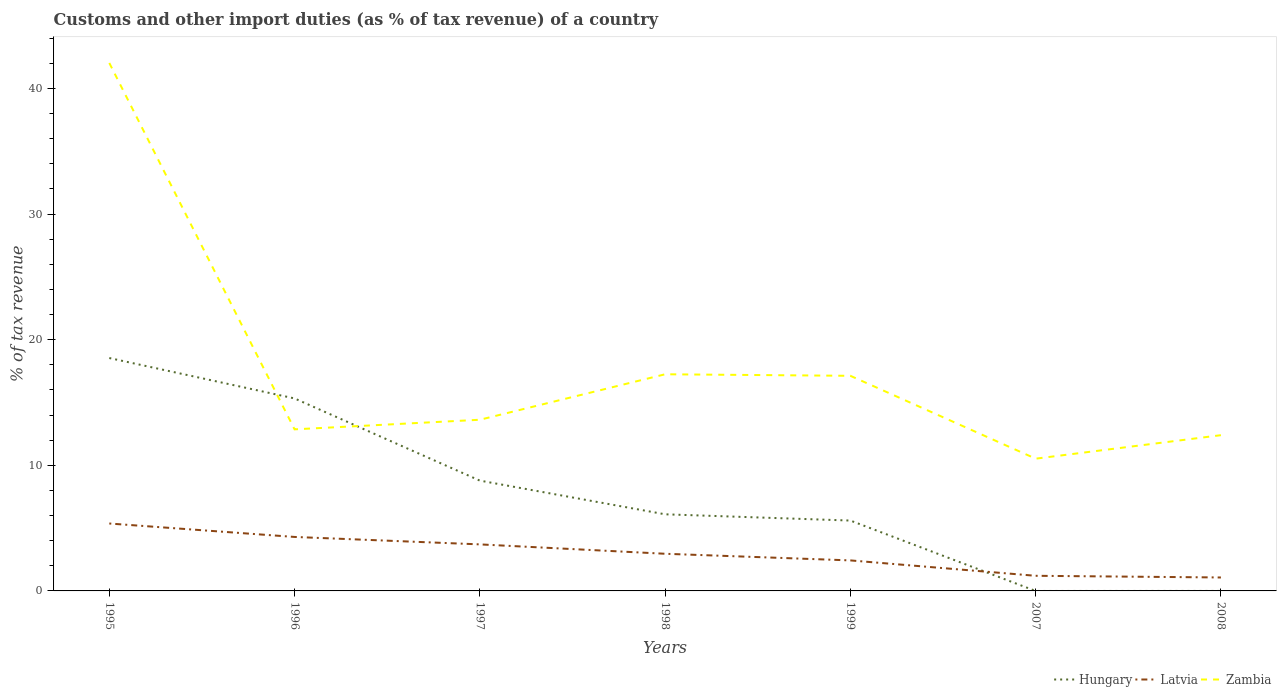Is the number of lines equal to the number of legend labels?
Ensure brevity in your answer.  No. What is the total percentage of tax revenue from customs in Zambia in the graph?
Ensure brevity in your answer.  24.9. What is the difference between the highest and the second highest percentage of tax revenue from customs in Latvia?
Give a very brief answer. 4.3. What is the difference between the highest and the lowest percentage of tax revenue from customs in Hungary?
Make the answer very short. 3. Is the percentage of tax revenue from customs in Hungary strictly greater than the percentage of tax revenue from customs in Latvia over the years?
Offer a very short reply. No. Are the values on the major ticks of Y-axis written in scientific E-notation?
Give a very brief answer. No. Does the graph contain any zero values?
Offer a terse response. Yes. Where does the legend appear in the graph?
Your answer should be compact. Bottom right. How are the legend labels stacked?
Give a very brief answer. Horizontal. What is the title of the graph?
Provide a short and direct response. Customs and other import duties (as % of tax revenue) of a country. What is the label or title of the Y-axis?
Offer a very short reply. % of tax revenue. What is the % of tax revenue of Hungary in 1995?
Provide a succinct answer. 18.54. What is the % of tax revenue in Latvia in 1995?
Ensure brevity in your answer.  5.37. What is the % of tax revenue in Zambia in 1995?
Keep it short and to the point. 42.02. What is the % of tax revenue of Hungary in 1996?
Keep it short and to the point. 15.32. What is the % of tax revenue of Latvia in 1996?
Provide a short and direct response. 4.3. What is the % of tax revenue in Zambia in 1996?
Give a very brief answer. 12.86. What is the % of tax revenue of Hungary in 1997?
Make the answer very short. 8.78. What is the % of tax revenue in Latvia in 1997?
Ensure brevity in your answer.  3.7. What is the % of tax revenue of Zambia in 1997?
Provide a succinct answer. 13.62. What is the % of tax revenue of Hungary in 1998?
Provide a succinct answer. 6.1. What is the % of tax revenue of Latvia in 1998?
Your answer should be very brief. 2.96. What is the % of tax revenue of Zambia in 1998?
Make the answer very short. 17.24. What is the % of tax revenue in Hungary in 1999?
Make the answer very short. 5.6. What is the % of tax revenue in Latvia in 1999?
Your answer should be very brief. 2.43. What is the % of tax revenue of Zambia in 1999?
Make the answer very short. 17.12. What is the % of tax revenue of Latvia in 2007?
Provide a succinct answer. 1.2. What is the % of tax revenue of Zambia in 2007?
Your answer should be compact. 10.53. What is the % of tax revenue in Hungary in 2008?
Provide a succinct answer. 0. What is the % of tax revenue of Latvia in 2008?
Offer a very short reply. 1.07. What is the % of tax revenue of Zambia in 2008?
Your answer should be very brief. 12.4. Across all years, what is the maximum % of tax revenue in Hungary?
Provide a succinct answer. 18.54. Across all years, what is the maximum % of tax revenue of Latvia?
Ensure brevity in your answer.  5.37. Across all years, what is the maximum % of tax revenue of Zambia?
Keep it short and to the point. 42.02. Across all years, what is the minimum % of tax revenue in Latvia?
Make the answer very short. 1.07. Across all years, what is the minimum % of tax revenue of Zambia?
Offer a very short reply. 10.53. What is the total % of tax revenue of Hungary in the graph?
Offer a very short reply. 54.34. What is the total % of tax revenue of Latvia in the graph?
Keep it short and to the point. 21.03. What is the total % of tax revenue in Zambia in the graph?
Provide a short and direct response. 125.8. What is the difference between the % of tax revenue in Hungary in 1995 and that in 1996?
Keep it short and to the point. 3.22. What is the difference between the % of tax revenue of Latvia in 1995 and that in 1996?
Your answer should be compact. 1.07. What is the difference between the % of tax revenue of Zambia in 1995 and that in 1996?
Ensure brevity in your answer.  29.16. What is the difference between the % of tax revenue of Hungary in 1995 and that in 1997?
Give a very brief answer. 9.76. What is the difference between the % of tax revenue in Latvia in 1995 and that in 1997?
Provide a succinct answer. 1.66. What is the difference between the % of tax revenue in Zambia in 1995 and that in 1997?
Offer a very short reply. 28.4. What is the difference between the % of tax revenue in Hungary in 1995 and that in 1998?
Offer a very short reply. 12.44. What is the difference between the % of tax revenue of Latvia in 1995 and that in 1998?
Keep it short and to the point. 2.41. What is the difference between the % of tax revenue of Zambia in 1995 and that in 1998?
Provide a short and direct response. 24.78. What is the difference between the % of tax revenue of Hungary in 1995 and that in 1999?
Offer a terse response. 12.94. What is the difference between the % of tax revenue of Latvia in 1995 and that in 1999?
Offer a very short reply. 2.94. What is the difference between the % of tax revenue of Zambia in 1995 and that in 1999?
Provide a succinct answer. 24.9. What is the difference between the % of tax revenue of Latvia in 1995 and that in 2007?
Your answer should be compact. 4.16. What is the difference between the % of tax revenue of Zambia in 1995 and that in 2007?
Provide a succinct answer. 31.5. What is the difference between the % of tax revenue in Latvia in 1995 and that in 2008?
Provide a succinct answer. 4.3. What is the difference between the % of tax revenue in Zambia in 1995 and that in 2008?
Keep it short and to the point. 29.63. What is the difference between the % of tax revenue of Hungary in 1996 and that in 1997?
Your response must be concise. 6.54. What is the difference between the % of tax revenue in Latvia in 1996 and that in 1997?
Provide a short and direct response. 0.59. What is the difference between the % of tax revenue in Zambia in 1996 and that in 1997?
Give a very brief answer. -0.76. What is the difference between the % of tax revenue in Hungary in 1996 and that in 1998?
Your answer should be compact. 9.22. What is the difference between the % of tax revenue of Latvia in 1996 and that in 1998?
Offer a terse response. 1.34. What is the difference between the % of tax revenue of Zambia in 1996 and that in 1998?
Give a very brief answer. -4.38. What is the difference between the % of tax revenue in Hungary in 1996 and that in 1999?
Provide a short and direct response. 9.72. What is the difference between the % of tax revenue in Latvia in 1996 and that in 1999?
Keep it short and to the point. 1.87. What is the difference between the % of tax revenue in Zambia in 1996 and that in 1999?
Keep it short and to the point. -4.26. What is the difference between the % of tax revenue in Latvia in 1996 and that in 2007?
Give a very brief answer. 3.09. What is the difference between the % of tax revenue in Zambia in 1996 and that in 2007?
Give a very brief answer. 2.33. What is the difference between the % of tax revenue in Latvia in 1996 and that in 2008?
Your response must be concise. 3.23. What is the difference between the % of tax revenue in Zambia in 1996 and that in 2008?
Provide a short and direct response. 0.46. What is the difference between the % of tax revenue in Hungary in 1997 and that in 1998?
Offer a terse response. 2.68. What is the difference between the % of tax revenue in Latvia in 1997 and that in 1998?
Offer a terse response. 0.75. What is the difference between the % of tax revenue in Zambia in 1997 and that in 1998?
Provide a succinct answer. -3.62. What is the difference between the % of tax revenue in Hungary in 1997 and that in 1999?
Make the answer very short. 3.18. What is the difference between the % of tax revenue of Latvia in 1997 and that in 1999?
Your answer should be very brief. 1.28. What is the difference between the % of tax revenue of Zambia in 1997 and that in 1999?
Make the answer very short. -3.5. What is the difference between the % of tax revenue of Latvia in 1997 and that in 2007?
Provide a succinct answer. 2.5. What is the difference between the % of tax revenue of Zambia in 1997 and that in 2007?
Offer a very short reply. 3.1. What is the difference between the % of tax revenue of Latvia in 1997 and that in 2008?
Keep it short and to the point. 2.63. What is the difference between the % of tax revenue of Zambia in 1997 and that in 2008?
Your answer should be very brief. 1.23. What is the difference between the % of tax revenue in Hungary in 1998 and that in 1999?
Provide a short and direct response. 0.5. What is the difference between the % of tax revenue in Latvia in 1998 and that in 1999?
Give a very brief answer. 0.53. What is the difference between the % of tax revenue in Zambia in 1998 and that in 1999?
Keep it short and to the point. 0.12. What is the difference between the % of tax revenue of Latvia in 1998 and that in 2007?
Offer a terse response. 1.75. What is the difference between the % of tax revenue in Zambia in 1998 and that in 2007?
Provide a short and direct response. 6.72. What is the difference between the % of tax revenue in Latvia in 1998 and that in 2008?
Provide a short and direct response. 1.89. What is the difference between the % of tax revenue of Zambia in 1998 and that in 2008?
Provide a succinct answer. 4.85. What is the difference between the % of tax revenue in Latvia in 1999 and that in 2007?
Your answer should be very brief. 1.23. What is the difference between the % of tax revenue in Zambia in 1999 and that in 2007?
Keep it short and to the point. 6.6. What is the difference between the % of tax revenue in Latvia in 1999 and that in 2008?
Ensure brevity in your answer.  1.36. What is the difference between the % of tax revenue of Zambia in 1999 and that in 2008?
Keep it short and to the point. 4.73. What is the difference between the % of tax revenue in Latvia in 2007 and that in 2008?
Your answer should be very brief. 0.13. What is the difference between the % of tax revenue in Zambia in 2007 and that in 2008?
Offer a very short reply. -1.87. What is the difference between the % of tax revenue in Hungary in 1995 and the % of tax revenue in Latvia in 1996?
Give a very brief answer. 14.24. What is the difference between the % of tax revenue of Hungary in 1995 and the % of tax revenue of Zambia in 1996?
Keep it short and to the point. 5.68. What is the difference between the % of tax revenue in Latvia in 1995 and the % of tax revenue in Zambia in 1996?
Ensure brevity in your answer.  -7.49. What is the difference between the % of tax revenue in Hungary in 1995 and the % of tax revenue in Latvia in 1997?
Provide a short and direct response. 14.83. What is the difference between the % of tax revenue in Hungary in 1995 and the % of tax revenue in Zambia in 1997?
Make the answer very short. 4.91. What is the difference between the % of tax revenue in Latvia in 1995 and the % of tax revenue in Zambia in 1997?
Your answer should be very brief. -8.26. What is the difference between the % of tax revenue in Hungary in 1995 and the % of tax revenue in Latvia in 1998?
Your response must be concise. 15.58. What is the difference between the % of tax revenue in Hungary in 1995 and the % of tax revenue in Zambia in 1998?
Make the answer very short. 1.29. What is the difference between the % of tax revenue in Latvia in 1995 and the % of tax revenue in Zambia in 1998?
Provide a short and direct response. -11.88. What is the difference between the % of tax revenue in Hungary in 1995 and the % of tax revenue in Latvia in 1999?
Make the answer very short. 16.11. What is the difference between the % of tax revenue in Hungary in 1995 and the % of tax revenue in Zambia in 1999?
Your answer should be compact. 1.42. What is the difference between the % of tax revenue in Latvia in 1995 and the % of tax revenue in Zambia in 1999?
Provide a succinct answer. -11.76. What is the difference between the % of tax revenue of Hungary in 1995 and the % of tax revenue of Latvia in 2007?
Your answer should be compact. 17.33. What is the difference between the % of tax revenue in Hungary in 1995 and the % of tax revenue in Zambia in 2007?
Your answer should be very brief. 8.01. What is the difference between the % of tax revenue in Latvia in 1995 and the % of tax revenue in Zambia in 2007?
Your answer should be very brief. -5.16. What is the difference between the % of tax revenue of Hungary in 1995 and the % of tax revenue of Latvia in 2008?
Ensure brevity in your answer.  17.47. What is the difference between the % of tax revenue of Hungary in 1995 and the % of tax revenue of Zambia in 2008?
Your answer should be compact. 6.14. What is the difference between the % of tax revenue of Latvia in 1995 and the % of tax revenue of Zambia in 2008?
Make the answer very short. -7.03. What is the difference between the % of tax revenue in Hungary in 1996 and the % of tax revenue in Latvia in 1997?
Make the answer very short. 11.62. What is the difference between the % of tax revenue of Hungary in 1996 and the % of tax revenue of Zambia in 1997?
Provide a succinct answer. 1.7. What is the difference between the % of tax revenue in Latvia in 1996 and the % of tax revenue in Zambia in 1997?
Offer a very short reply. -9.33. What is the difference between the % of tax revenue of Hungary in 1996 and the % of tax revenue of Latvia in 1998?
Provide a short and direct response. 12.36. What is the difference between the % of tax revenue in Hungary in 1996 and the % of tax revenue in Zambia in 1998?
Give a very brief answer. -1.92. What is the difference between the % of tax revenue in Latvia in 1996 and the % of tax revenue in Zambia in 1998?
Ensure brevity in your answer.  -12.95. What is the difference between the % of tax revenue of Hungary in 1996 and the % of tax revenue of Latvia in 1999?
Keep it short and to the point. 12.89. What is the difference between the % of tax revenue in Hungary in 1996 and the % of tax revenue in Zambia in 1999?
Give a very brief answer. -1.8. What is the difference between the % of tax revenue in Latvia in 1996 and the % of tax revenue in Zambia in 1999?
Ensure brevity in your answer.  -12.83. What is the difference between the % of tax revenue of Hungary in 1996 and the % of tax revenue of Latvia in 2007?
Your response must be concise. 14.12. What is the difference between the % of tax revenue in Hungary in 1996 and the % of tax revenue in Zambia in 2007?
Give a very brief answer. 4.79. What is the difference between the % of tax revenue in Latvia in 1996 and the % of tax revenue in Zambia in 2007?
Keep it short and to the point. -6.23. What is the difference between the % of tax revenue in Hungary in 1996 and the % of tax revenue in Latvia in 2008?
Your answer should be compact. 14.25. What is the difference between the % of tax revenue in Hungary in 1996 and the % of tax revenue in Zambia in 2008?
Keep it short and to the point. 2.92. What is the difference between the % of tax revenue of Latvia in 1996 and the % of tax revenue of Zambia in 2008?
Your answer should be very brief. -8.1. What is the difference between the % of tax revenue in Hungary in 1997 and the % of tax revenue in Latvia in 1998?
Ensure brevity in your answer.  5.82. What is the difference between the % of tax revenue of Hungary in 1997 and the % of tax revenue of Zambia in 1998?
Your answer should be compact. -8.46. What is the difference between the % of tax revenue of Latvia in 1997 and the % of tax revenue of Zambia in 1998?
Provide a short and direct response. -13.54. What is the difference between the % of tax revenue in Hungary in 1997 and the % of tax revenue in Latvia in 1999?
Make the answer very short. 6.35. What is the difference between the % of tax revenue in Hungary in 1997 and the % of tax revenue in Zambia in 1999?
Provide a succinct answer. -8.34. What is the difference between the % of tax revenue of Latvia in 1997 and the % of tax revenue of Zambia in 1999?
Give a very brief answer. -13.42. What is the difference between the % of tax revenue of Hungary in 1997 and the % of tax revenue of Latvia in 2007?
Your response must be concise. 7.58. What is the difference between the % of tax revenue of Hungary in 1997 and the % of tax revenue of Zambia in 2007?
Provide a succinct answer. -1.75. What is the difference between the % of tax revenue of Latvia in 1997 and the % of tax revenue of Zambia in 2007?
Your answer should be very brief. -6.82. What is the difference between the % of tax revenue in Hungary in 1997 and the % of tax revenue in Latvia in 2008?
Your response must be concise. 7.71. What is the difference between the % of tax revenue of Hungary in 1997 and the % of tax revenue of Zambia in 2008?
Your answer should be very brief. -3.62. What is the difference between the % of tax revenue in Latvia in 1997 and the % of tax revenue in Zambia in 2008?
Provide a short and direct response. -8.69. What is the difference between the % of tax revenue of Hungary in 1998 and the % of tax revenue of Latvia in 1999?
Offer a very short reply. 3.67. What is the difference between the % of tax revenue of Hungary in 1998 and the % of tax revenue of Zambia in 1999?
Provide a short and direct response. -11.02. What is the difference between the % of tax revenue in Latvia in 1998 and the % of tax revenue in Zambia in 1999?
Keep it short and to the point. -14.16. What is the difference between the % of tax revenue in Hungary in 1998 and the % of tax revenue in Latvia in 2007?
Provide a succinct answer. 4.89. What is the difference between the % of tax revenue in Hungary in 1998 and the % of tax revenue in Zambia in 2007?
Your answer should be very brief. -4.43. What is the difference between the % of tax revenue in Latvia in 1998 and the % of tax revenue in Zambia in 2007?
Your answer should be compact. -7.57. What is the difference between the % of tax revenue of Hungary in 1998 and the % of tax revenue of Latvia in 2008?
Provide a short and direct response. 5.03. What is the difference between the % of tax revenue of Hungary in 1998 and the % of tax revenue of Zambia in 2008?
Make the answer very short. -6.3. What is the difference between the % of tax revenue in Latvia in 1998 and the % of tax revenue in Zambia in 2008?
Your answer should be compact. -9.44. What is the difference between the % of tax revenue of Hungary in 1999 and the % of tax revenue of Latvia in 2007?
Provide a succinct answer. 4.4. What is the difference between the % of tax revenue in Hungary in 1999 and the % of tax revenue in Zambia in 2007?
Ensure brevity in your answer.  -4.93. What is the difference between the % of tax revenue of Latvia in 1999 and the % of tax revenue of Zambia in 2007?
Your response must be concise. -8.1. What is the difference between the % of tax revenue in Hungary in 1999 and the % of tax revenue in Latvia in 2008?
Offer a very short reply. 4.53. What is the difference between the % of tax revenue of Hungary in 1999 and the % of tax revenue of Zambia in 2008?
Offer a terse response. -6.8. What is the difference between the % of tax revenue of Latvia in 1999 and the % of tax revenue of Zambia in 2008?
Provide a succinct answer. -9.97. What is the difference between the % of tax revenue of Latvia in 2007 and the % of tax revenue of Zambia in 2008?
Offer a terse response. -11.19. What is the average % of tax revenue of Hungary per year?
Keep it short and to the point. 7.76. What is the average % of tax revenue of Latvia per year?
Provide a succinct answer. 3. What is the average % of tax revenue of Zambia per year?
Provide a succinct answer. 17.97. In the year 1995, what is the difference between the % of tax revenue of Hungary and % of tax revenue of Latvia?
Make the answer very short. 13.17. In the year 1995, what is the difference between the % of tax revenue of Hungary and % of tax revenue of Zambia?
Give a very brief answer. -23.49. In the year 1995, what is the difference between the % of tax revenue in Latvia and % of tax revenue in Zambia?
Your answer should be very brief. -36.66. In the year 1996, what is the difference between the % of tax revenue of Hungary and % of tax revenue of Latvia?
Provide a short and direct response. 11.03. In the year 1996, what is the difference between the % of tax revenue in Hungary and % of tax revenue in Zambia?
Provide a short and direct response. 2.46. In the year 1996, what is the difference between the % of tax revenue of Latvia and % of tax revenue of Zambia?
Ensure brevity in your answer.  -8.56. In the year 1997, what is the difference between the % of tax revenue in Hungary and % of tax revenue in Latvia?
Keep it short and to the point. 5.08. In the year 1997, what is the difference between the % of tax revenue of Hungary and % of tax revenue of Zambia?
Make the answer very short. -4.84. In the year 1997, what is the difference between the % of tax revenue in Latvia and % of tax revenue in Zambia?
Make the answer very short. -9.92. In the year 1998, what is the difference between the % of tax revenue of Hungary and % of tax revenue of Latvia?
Make the answer very short. 3.14. In the year 1998, what is the difference between the % of tax revenue of Hungary and % of tax revenue of Zambia?
Keep it short and to the point. -11.15. In the year 1998, what is the difference between the % of tax revenue in Latvia and % of tax revenue in Zambia?
Provide a short and direct response. -14.29. In the year 1999, what is the difference between the % of tax revenue of Hungary and % of tax revenue of Latvia?
Keep it short and to the point. 3.17. In the year 1999, what is the difference between the % of tax revenue of Hungary and % of tax revenue of Zambia?
Your response must be concise. -11.52. In the year 1999, what is the difference between the % of tax revenue in Latvia and % of tax revenue in Zambia?
Give a very brief answer. -14.69. In the year 2007, what is the difference between the % of tax revenue of Latvia and % of tax revenue of Zambia?
Offer a terse response. -9.32. In the year 2008, what is the difference between the % of tax revenue of Latvia and % of tax revenue of Zambia?
Ensure brevity in your answer.  -11.33. What is the ratio of the % of tax revenue of Hungary in 1995 to that in 1996?
Ensure brevity in your answer.  1.21. What is the ratio of the % of tax revenue in Latvia in 1995 to that in 1996?
Give a very brief answer. 1.25. What is the ratio of the % of tax revenue in Zambia in 1995 to that in 1996?
Provide a short and direct response. 3.27. What is the ratio of the % of tax revenue of Hungary in 1995 to that in 1997?
Make the answer very short. 2.11. What is the ratio of the % of tax revenue in Latvia in 1995 to that in 1997?
Give a very brief answer. 1.45. What is the ratio of the % of tax revenue in Zambia in 1995 to that in 1997?
Your answer should be very brief. 3.08. What is the ratio of the % of tax revenue in Hungary in 1995 to that in 1998?
Offer a terse response. 3.04. What is the ratio of the % of tax revenue of Latvia in 1995 to that in 1998?
Keep it short and to the point. 1.81. What is the ratio of the % of tax revenue of Zambia in 1995 to that in 1998?
Offer a terse response. 2.44. What is the ratio of the % of tax revenue in Hungary in 1995 to that in 1999?
Your response must be concise. 3.31. What is the ratio of the % of tax revenue in Latvia in 1995 to that in 1999?
Provide a short and direct response. 2.21. What is the ratio of the % of tax revenue in Zambia in 1995 to that in 1999?
Make the answer very short. 2.45. What is the ratio of the % of tax revenue in Latvia in 1995 to that in 2007?
Offer a terse response. 4.46. What is the ratio of the % of tax revenue of Zambia in 1995 to that in 2007?
Offer a terse response. 3.99. What is the ratio of the % of tax revenue of Latvia in 1995 to that in 2008?
Offer a very short reply. 5.02. What is the ratio of the % of tax revenue of Zambia in 1995 to that in 2008?
Make the answer very short. 3.39. What is the ratio of the % of tax revenue in Hungary in 1996 to that in 1997?
Offer a very short reply. 1.74. What is the ratio of the % of tax revenue of Latvia in 1996 to that in 1997?
Offer a terse response. 1.16. What is the ratio of the % of tax revenue in Zambia in 1996 to that in 1997?
Give a very brief answer. 0.94. What is the ratio of the % of tax revenue in Hungary in 1996 to that in 1998?
Offer a very short reply. 2.51. What is the ratio of the % of tax revenue in Latvia in 1996 to that in 1998?
Your response must be concise. 1.45. What is the ratio of the % of tax revenue in Zambia in 1996 to that in 1998?
Ensure brevity in your answer.  0.75. What is the ratio of the % of tax revenue in Hungary in 1996 to that in 1999?
Ensure brevity in your answer.  2.74. What is the ratio of the % of tax revenue of Latvia in 1996 to that in 1999?
Give a very brief answer. 1.77. What is the ratio of the % of tax revenue in Zambia in 1996 to that in 1999?
Your answer should be compact. 0.75. What is the ratio of the % of tax revenue in Latvia in 1996 to that in 2007?
Your response must be concise. 3.57. What is the ratio of the % of tax revenue in Zambia in 1996 to that in 2007?
Your response must be concise. 1.22. What is the ratio of the % of tax revenue of Latvia in 1996 to that in 2008?
Offer a very short reply. 4.02. What is the ratio of the % of tax revenue in Zambia in 1996 to that in 2008?
Give a very brief answer. 1.04. What is the ratio of the % of tax revenue in Hungary in 1997 to that in 1998?
Provide a short and direct response. 1.44. What is the ratio of the % of tax revenue in Latvia in 1997 to that in 1998?
Offer a very short reply. 1.25. What is the ratio of the % of tax revenue of Zambia in 1997 to that in 1998?
Your answer should be very brief. 0.79. What is the ratio of the % of tax revenue in Hungary in 1997 to that in 1999?
Provide a short and direct response. 1.57. What is the ratio of the % of tax revenue in Latvia in 1997 to that in 1999?
Give a very brief answer. 1.52. What is the ratio of the % of tax revenue of Zambia in 1997 to that in 1999?
Ensure brevity in your answer.  0.8. What is the ratio of the % of tax revenue in Latvia in 1997 to that in 2007?
Ensure brevity in your answer.  3.08. What is the ratio of the % of tax revenue in Zambia in 1997 to that in 2007?
Give a very brief answer. 1.29. What is the ratio of the % of tax revenue of Latvia in 1997 to that in 2008?
Keep it short and to the point. 3.46. What is the ratio of the % of tax revenue of Zambia in 1997 to that in 2008?
Provide a succinct answer. 1.1. What is the ratio of the % of tax revenue of Hungary in 1998 to that in 1999?
Ensure brevity in your answer.  1.09. What is the ratio of the % of tax revenue of Latvia in 1998 to that in 1999?
Offer a very short reply. 1.22. What is the ratio of the % of tax revenue of Zambia in 1998 to that in 1999?
Provide a short and direct response. 1.01. What is the ratio of the % of tax revenue in Latvia in 1998 to that in 2007?
Provide a short and direct response. 2.46. What is the ratio of the % of tax revenue in Zambia in 1998 to that in 2007?
Your response must be concise. 1.64. What is the ratio of the % of tax revenue of Latvia in 1998 to that in 2008?
Keep it short and to the point. 2.76. What is the ratio of the % of tax revenue of Zambia in 1998 to that in 2008?
Ensure brevity in your answer.  1.39. What is the ratio of the % of tax revenue in Latvia in 1999 to that in 2007?
Make the answer very short. 2.02. What is the ratio of the % of tax revenue in Zambia in 1999 to that in 2007?
Give a very brief answer. 1.63. What is the ratio of the % of tax revenue of Latvia in 1999 to that in 2008?
Ensure brevity in your answer.  2.27. What is the ratio of the % of tax revenue of Zambia in 1999 to that in 2008?
Offer a very short reply. 1.38. What is the ratio of the % of tax revenue in Latvia in 2007 to that in 2008?
Your answer should be very brief. 1.13. What is the ratio of the % of tax revenue of Zambia in 2007 to that in 2008?
Your answer should be very brief. 0.85. What is the difference between the highest and the second highest % of tax revenue in Hungary?
Your response must be concise. 3.22. What is the difference between the highest and the second highest % of tax revenue in Latvia?
Your answer should be compact. 1.07. What is the difference between the highest and the second highest % of tax revenue in Zambia?
Your answer should be very brief. 24.78. What is the difference between the highest and the lowest % of tax revenue in Hungary?
Provide a succinct answer. 18.54. What is the difference between the highest and the lowest % of tax revenue in Latvia?
Provide a short and direct response. 4.3. What is the difference between the highest and the lowest % of tax revenue in Zambia?
Offer a terse response. 31.5. 